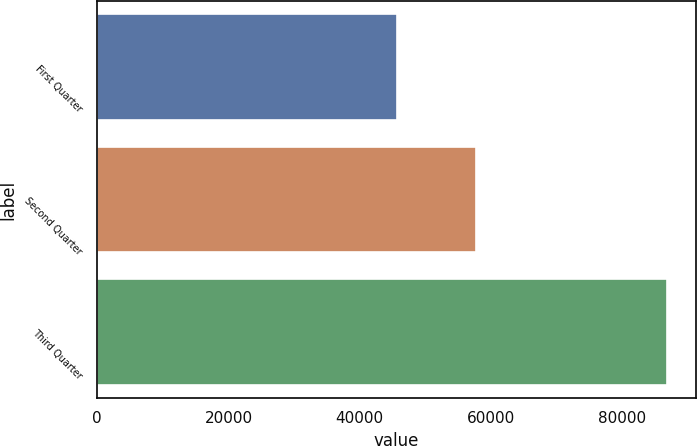Convert chart. <chart><loc_0><loc_0><loc_500><loc_500><bar_chart><fcel>First Quarter<fcel>Second Quarter<fcel>Third Quarter<nl><fcel>45593<fcel>57682<fcel>86810<nl></chart> 